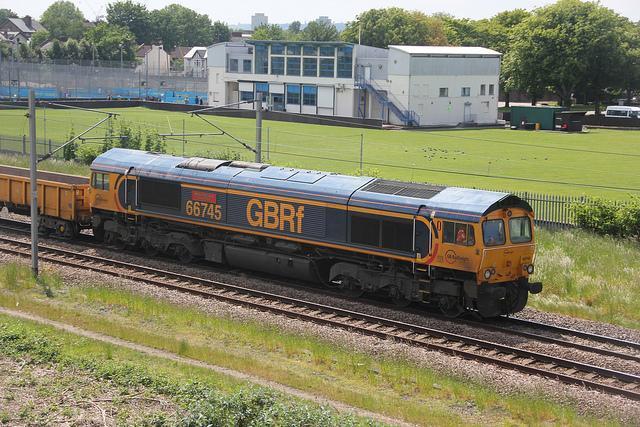How many tracks on the ground?
Give a very brief answer. 2. 